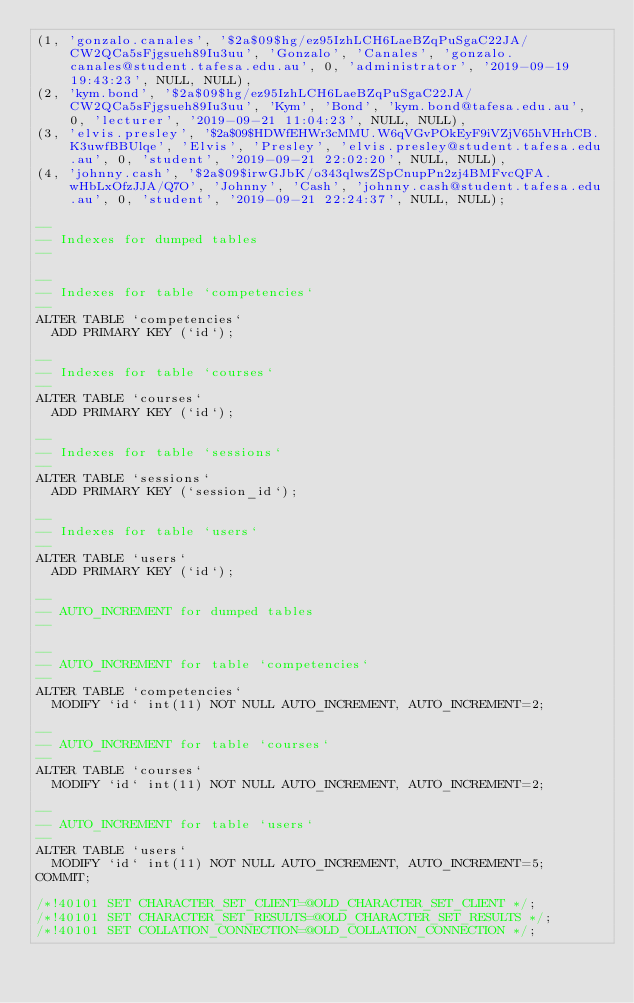<code> <loc_0><loc_0><loc_500><loc_500><_SQL_>(1, 'gonzalo.canales', '$2a$09$hg/ez95IzhLCH6LaeBZqPuSgaC22JA/CW2QCa5sFjgsueh89Iu3uu', 'Gonzalo', 'Canales', 'gonzalo.canales@student.tafesa.edu.au', 0, 'administrator', '2019-09-19 19:43:23', NULL, NULL),
(2, 'kym.bond', '$2a$09$hg/ez95IzhLCH6LaeBZqPuSgaC22JA/CW2QCa5sFjgsueh89Iu3uu', 'Kym', 'Bond', 'kym.bond@tafesa.edu.au', 0, 'lecturer', '2019-09-21 11:04:23', NULL, NULL),
(3, 'elvis.presley', '$2a$09$HDWfEHWr3cMMU.W6qVGvPOkEyF9iVZjV65hVHrhCB.K3uwfBBUlqe', 'Elvis', 'Presley', 'elvis.presley@student.tafesa.edu.au', 0, 'student', '2019-09-21 22:02:20', NULL, NULL),
(4, 'johnny.cash', '$2a$09$irwGJbK/o343qlwsZSpCnupPn2zj4BMFvcQFA.wHbLxOfzJJA/Q7O', 'Johnny', 'Cash', 'johnny.cash@student.tafesa.edu.au', 0, 'student', '2019-09-21 22:24:37', NULL, NULL);

--
-- Indexes for dumped tables
--

--
-- Indexes for table `competencies`
--
ALTER TABLE `competencies`
  ADD PRIMARY KEY (`id`);

--
-- Indexes for table `courses`
--
ALTER TABLE `courses`
  ADD PRIMARY KEY (`id`);

--
-- Indexes for table `sessions`
--
ALTER TABLE `sessions`
  ADD PRIMARY KEY (`session_id`);

--
-- Indexes for table `users`
--
ALTER TABLE `users`
  ADD PRIMARY KEY (`id`);

--
-- AUTO_INCREMENT for dumped tables
--

--
-- AUTO_INCREMENT for table `competencies`
--
ALTER TABLE `competencies`
  MODIFY `id` int(11) NOT NULL AUTO_INCREMENT, AUTO_INCREMENT=2;

--
-- AUTO_INCREMENT for table `courses`
--
ALTER TABLE `courses`
  MODIFY `id` int(11) NOT NULL AUTO_INCREMENT, AUTO_INCREMENT=2;

--
-- AUTO_INCREMENT for table `users`
--
ALTER TABLE `users`
  MODIFY `id` int(11) NOT NULL AUTO_INCREMENT, AUTO_INCREMENT=5;
COMMIT;

/*!40101 SET CHARACTER_SET_CLIENT=@OLD_CHARACTER_SET_CLIENT */;
/*!40101 SET CHARACTER_SET_RESULTS=@OLD_CHARACTER_SET_RESULTS */;
/*!40101 SET COLLATION_CONNECTION=@OLD_COLLATION_CONNECTION */;
</code> 